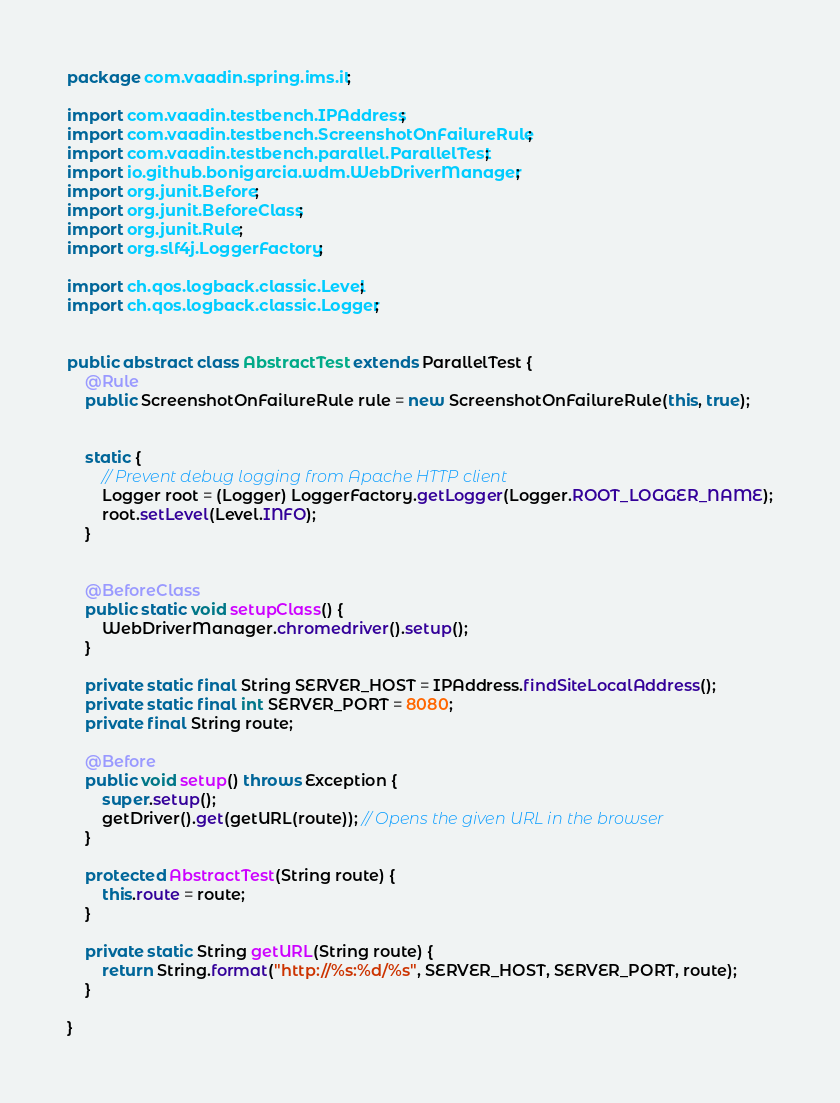<code> <loc_0><loc_0><loc_500><loc_500><_Java_>package com.vaadin.spring.ims.it;

import com.vaadin.testbench.IPAddress;
import com.vaadin.testbench.ScreenshotOnFailureRule;
import com.vaadin.testbench.parallel.ParallelTest;
import io.github.bonigarcia.wdm.WebDriverManager;
import org.junit.Before;
import org.junit.BeforeClass;
import org.junit.Rule;
import org.slf4j.LoggerFactory;

import ch.qos.logback.classic.Level;
import ch.qos.logback.classic.Logger;


public abstract class AbstractTest extends ParallelTest {
    @Rule
    public ScreenshotOnFailureRule rule = new ScreenshotOnFailureRule(this, true);


    static {
        // Prevent debug logging from Apache HTTP client
        Logger root = (Logger) LoggerFactory.getLogger(Logger.ROOT_LOGGER_NAME);
        root.setLevel(Level.INFO);
    }


    @BeforeClass
    public static void setupClass() {
        WebDriverManager.chromedriver().setup();
    }

    private static final String SERVER_HOST = IPAddress.findSiteLocalAddress();
    private static final int SERVER_PORT = 8080;
    private final String route;

    @Before
    public void setup() throws Exception {
        super.setup();
        getDriver().get(getURL(route)); // Opens the given URL in the browser
    }

    protected AbstractTest(String route) {
        this.route = route;
    }

    private static String getURL(String route) {
        return String.format("http://%s:%d/%s", SERVER_HOST, SERVER_PORT, route);
    }

}</code> 